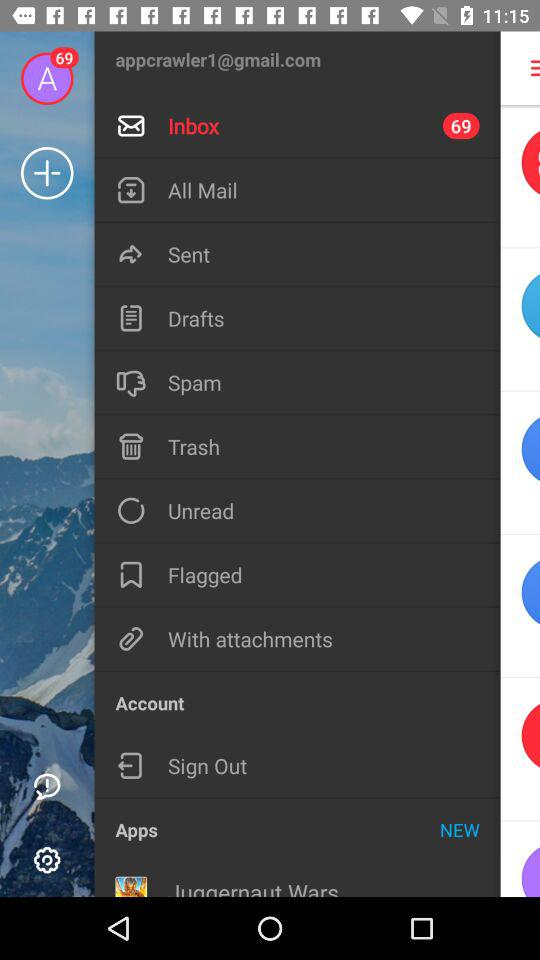How many messages are there in the inbox? There are 69 messages in the inbox. 